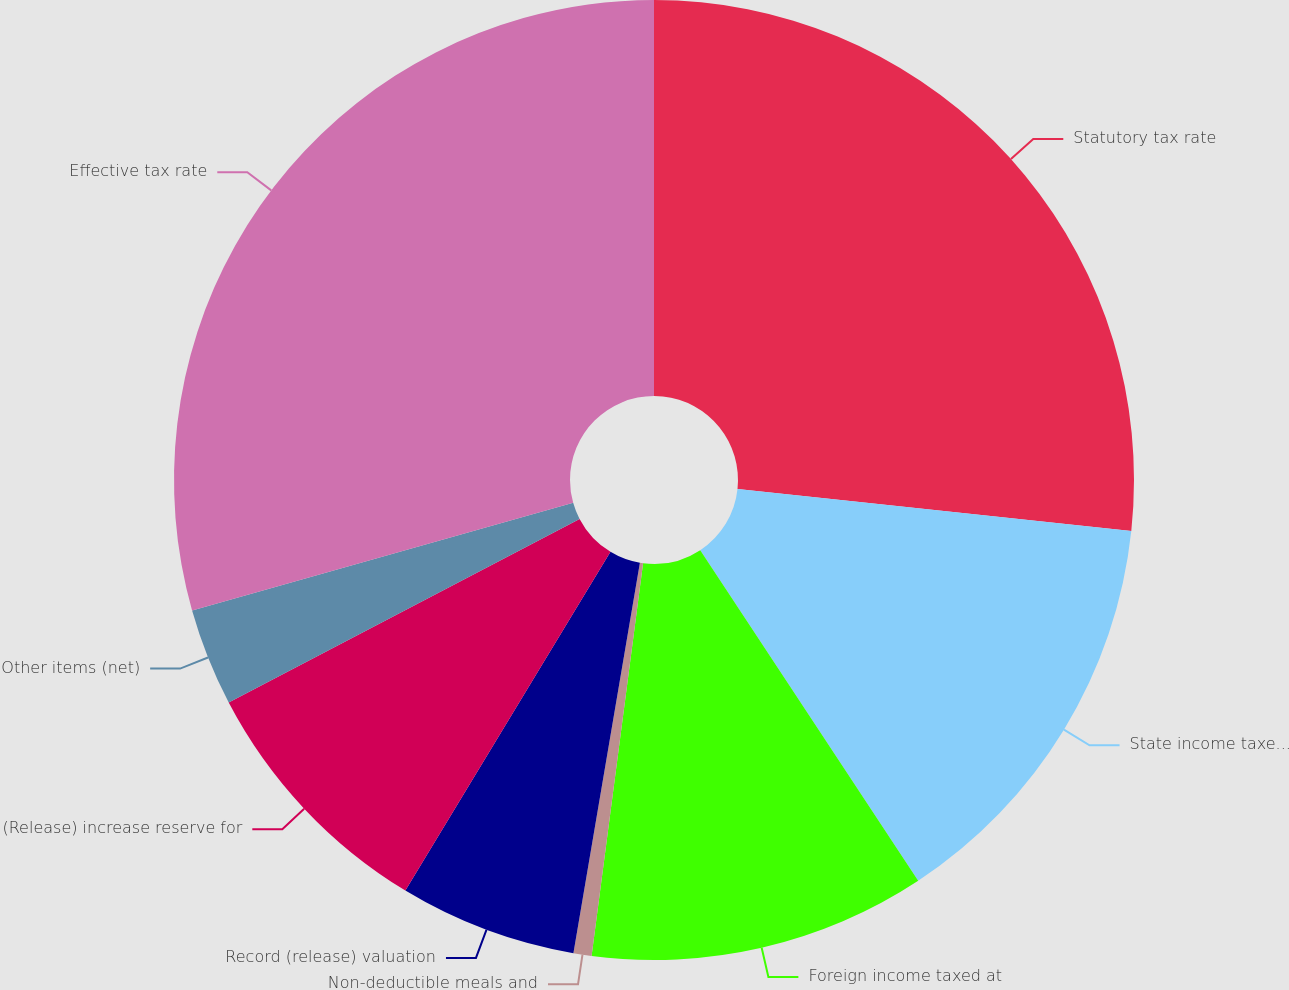Convert chart to OTSL. <chart><loc_0><loc_0><loc_500><loc_500><pie_chart><fcel>Statutory tax rate<fcel>State income taxes net of<fcel>Foreign income taxed at<fcel>Non-deductible meals and<fcel>Record (release) valuation<fcel>(Release) increase reserve for<fcel>Other items (net)<fcel>Effective tax rate<nl><fcel>26.69%<fcel>14.03%<fcel>11.35%<fcel>0.61%<fcel>5.98%<fcel>8.66%<fcel>3.29%<fcel>29.38%<nl></chart> 